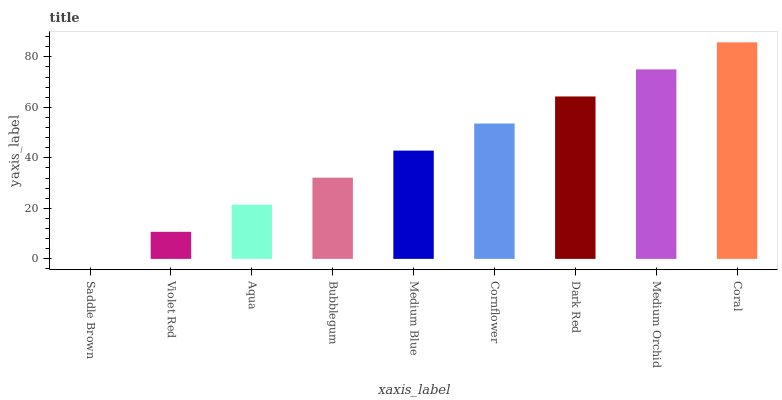Is Violet Red the minimum?
Answer yes or no. No. Is Violet Red the maximum?
Answer yes or no. No. Is Violet Red greater than Saddle Brown?
Answer yes or no. Yes. Is Saddle Brown less than Violet Red?
Answer yes or no. Yes. Is Saddle Brown greater than Violet Red?
Answer yes or no. No. Is Violet Red less than Saddle Brown?
Answer yes or no. No. Is Medium Blue the high median?
Answer yes or no. Yes. Is Medium Blue the low median?
Answer yes or no. Yes. Is Coral the high median?
Answer yes or no. No. Is Aqua the low median?
Answer yes or no. No. 